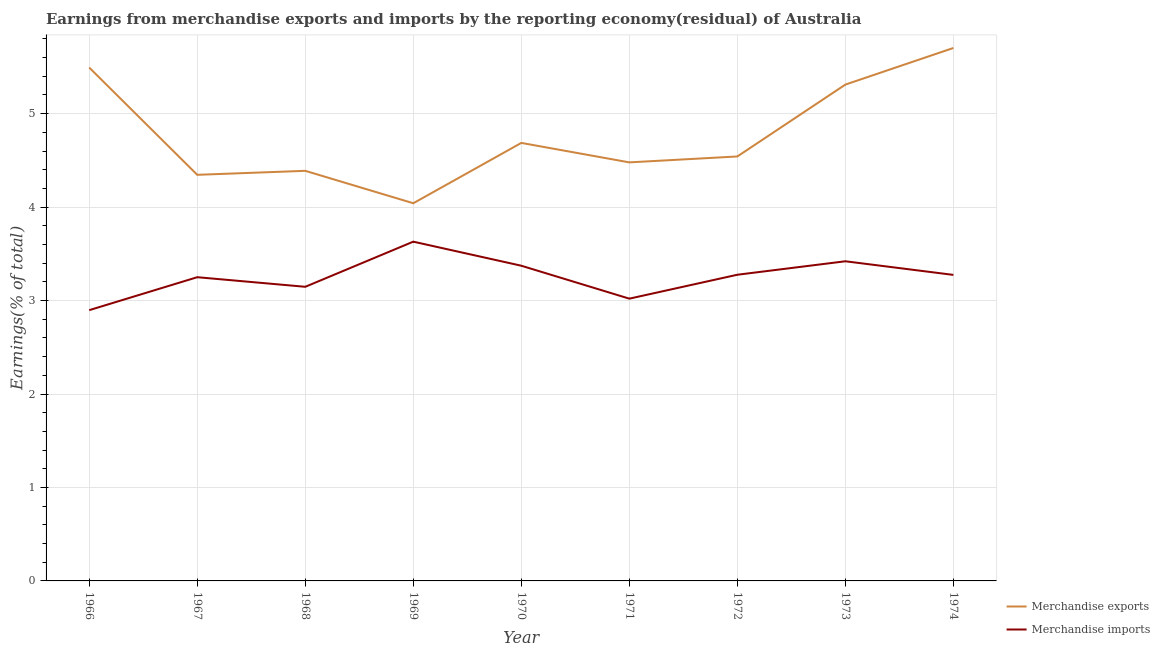Is the number of lines equal to the number of legend labels?
Provide a short and direct response. Yes. What is the earnings from merchandise imports in 1968?
Offer a very short reply. 3.15. Across all years, what is the maximum earnings from merchandise imports?
Offer a terse response. 3.63. Across all years, what is the minimum earnings from merchandise exports?
Offer a terse response. 4.04. In which year was the earnings from merchandise exports maximum?
Provide a short and direct response. 1974. In which year was the earnings from merchandise imports minimum?
Make the answer very short. 1966. What is the total earnings from merchandise exports in the graph?
Ensure brevity in your answer.  42.99. What is the difference between the earnings from merchandise imports in 1971 and that in 1972?
Provide a succinct answer. -0.26. What is the difference between the earnings from merchandise imports in 1974 and the earnings from merchandise exports in 1971?
Your response must be concise. -1.2. What is the average earnings from merchandise exports per year?
Offer a terse response. 4.78. In the year 1973, what is the difference between the earnings from merchandise exports and earnings from merchandise imports?
Offer a very short reply. 1.89. In how many years, is the earnings from merchandise exports greater than 4.4 %?
Keep it short and to the point. 6. What is the ratio of the earnings from merchandise exports in 1967 to that in 1971?
Offer a terse response. 0.97. Is the earnings from merchandise imports in 1970 less than that in 1974?
Your answer should be very brief. No. What is the difference between the highest and the second highest earnings from merchandise exports?
Your answer should be compact. 0.21. What is the difference between the highest and the lowest earnings from merchandise exports?
Ensure brevity in your answer.  1.66. Does the earnings from merchandise imports monotonically increase over the years?
Your answer should be compact. No. Is the earnings from merchandise imports strictly greater than the earnings from merchandise exports over the years?
Ensure brevity in your answer.  No. How many lines are there?
Provide a succinct answer. 2. Are the values on the major ticks of Y-axis written in scientific E-notation?
Give a very brief answer. No. Where does the legend appear in the graph?
Your response must be concise. Bottom right. How many legend labels are there?
Make the answer very short. 2. What is the title of the graph?
Keep it short and to the point. Earnings from merchandise exports and imports by the reporting economy(residual) of Australia. What is the label or title of the X-axis?
Ensure brevity in your answer.  Year. What is the label or title of the Y-axis?
Offer a very short reply. Earnings(% of total). What is the Earnings(% of total) in Merchandise exports in 1966?
Provide a short and direct response. 5.49. What is the Earnings(% of total) in Merchandise imports in 1966?
Offer a terse response. 2.9. What is the Earnings(% of total) of Merchandise exports in 1967?
Make the answer very short. 4.35. What is the Earnings(% of total) of Merchandise imports in 1967?
Your answer should be compact. 3.25. What is the Earnings(% of total) in Merchandise exports in 1968?
Ensure brevity in your answer.  4.39. What is the Earnings(% of total) in Merchandise imports in 1968?
Give a very brief answer. 3.15. What is the Earnings(% of total) of Merchandise exports in 1969?
Make the answer very short. 4.04. What is the Earnings(% of total) of Merchandise imports in 1969?
Your answer should be compact. 3.63. What is the Earnings(% of total) in Merchandise exports in 1970?
Make the answer very short. 4.69. What is the Earnings(% of total) of Merchandise imports in 1970?
Give a very brief answer. 3.37. What is the Earnings(% of total) of Merchandise exports in 1971?
Your answer should be very brief. 4.48. What is the Earnings(% of total) in Merchandise imports in 1971?
Your answer should be very brief. 3.02. What is the Earnings(% of total) in Merchandise exports in 1972?
Keep it short and to the point. 4.54. What is the Earnings(% of total) in Merchandise imports in 1972?
Your answer should be compact. 3.28. What is the Earnings(% of total) of Merchandise exports in 1973?
Your answer should be very brief. 5.31. What is the Earnings(% of total) of Merchandise imports in 1973?
Your response must be concise. 3.42. What is the Earnings(% of total) of Merchandise exports in 1974?
Make the answer very short. 5.7. What is the Earnings(% of total) in Merchandise imports in 1974?
Ensure brevity in your answer.  3.27. Across all years, what is the maximum Earnings(% of total) in Merchandise exports?
Offer a very short reply. 5.7. Across all years, what is the maximum Earnings(% of total) in Merchandise imports?
Provide a succinct answer. 3.63. Across all years, what is the minimum Earnings(% of total) in Merchandise exports?
Keep it short and to the point. 4.04. Across all years, what is the minimum Earnings(% of total) of Merchandise imports?
Provide a short and direct response. 2.9. What is the total Earnings(% of total) in Merchandise exports in the graph?
Make the answer very short. 42.99. What is the total Earnings(% of total) in Merchandise imports in the graph?
Give a very brief answer. 29.29. What is the difference between the Earnings(% of total) of Merchandise exports in 1966 and that in 1967?
Ensure brevity in your answer.  1.15. What is the difference between the Earnings(% of total) in Merchandise imports in 1966 and that in 1967?
Ensure brevity in your answer.  -0.35. What is the difference between the Earnings(% of total) of Merchandise exports in 1966 and that in 1968?
Keep it short and to the point. 1.1. What is the difference between the Earnings(% of total) of Merchandise exports in 1966 and that in 1969?
Provide a succinct answer. 1.45. What is the difference between the Earnings(% of total) of Merchandise imports in 1966 and that in 1969?
Keep it short and to the point. -0.73. What is the difference between the Earnings(% of total) of Merchandise exports in 1966 and that in 1970?
Give a very brief answer. 0.81. What is the difference between the Earnings(% of total) of Merchandise imports in 1966 and that in 1970?
Provide a short and direct response. -0.48. What is the difference between the Earnings(% of total) in Merchandise exports in 1966 and that in 1971?
Provide a short and direct response. 1.01. What is the difference between the Earnings(% of total) of Merchandise imports in 1966 and that in 1971?
Keep it short and to the point. -0.12. What is the difference between the Earnings(% of total) of Merchandise exports in 1966 and that in 1972?
Make the answer very short. 0.95. What is the difference between the Earnings(% of total) of Merchandise imports in 1966 and that in 1972?
Give a very brief answer. -0.38. What is the difference between the Earnings(% of total) of Merchandise exports in 1966 and that in 1973?
Give a very brief answer. 0.18. What is the difference between the Earnings(% of total) of Merchandise imports in 1966 and that in 1973?
Your answer should be very brief. -0.52. What is the difference between the Earnings(% of total) of Merchandise exports in 1966 and that in 1974?
Make the answer very short. -0.21. What is the difference between the Earnings(% of total) of Merchandise imports in 1966 and that in 1974?
Your response must be concise. -0.38. What is the difference between the Earnings(% of total) of Merchandise exports in 1967 and that in 1968?
Ensure brevity in your answer.  -0.04. What is the difference between the Earnings(% of total) in Merchandise imports in 1967 and that in 1968?
Give a very brief answer. 0.1. What is the difference between the Earnings(% of total) in Merchandise exports in 1967 and that in 1969?
Keep it short and to the point. 0.3. What is the difference between the Earnings(% of total) in Merchandise imports in 1967 and that in 1969?
Give a very brief answer. -0.38. What is the difference between the Earnings(% of total) in Merchandise exports in 1967 and that in 1970?
Make the answer very short. -0.34. What is the difference between the Earnings(% of total) in Merchandise imports in 1967 and that in 1970?
Ensure brevity in your answer.  -0.12. What is the difference between the Earnings(% of total) in Merchandise exports in 1967 and that in 1971?
Offer a terse response. -0.13. What is the difference between the Earnings(% of total) of Merchandise imports in 1967 and that in 1971?
Provide a succinct answer. 0.23. What is the difference between the Earnings(% of total) in Merchandise exports in 1967 and that in 1972?
Your answer should be very brief. -0.2. What is the difference between the Earnings(% of total) of Merchandise imports in 1967 and that in 1972?
Make the answer very short. -0.03. What is the difference between the Earnings(% of total) of Merchandise exports in 1967 and that in 1973?
Give a very brief answer. -0.97. What is the difference between the Earnings(% of total) of Merchandise imports in 1967 and that in 1973?
Provide a succinct answer. -0.17. What is the difference between the Earnings(% of total) in Merchandise exports in 1967 and that in 1974?
Ensure brevity in your answer.  -1.36. What is the difference between the Earnings(% of total) of Merchandise imports in 1967 and that in 1974?
Provide a succinct answer. -0.02. What is the difference between the Earnings(% of total) in Merchandise exports in 1968 and that in 1969?
Provide a succinct answer. 0.35. What is the difference between the Earnings(% of total) of Merchandise imports in 1968 and that in 1969?
Offer a very short reply. -0.48. What is the difference between the Earnings(% of total) in Merchandise exports in 1968 and that in 1970?
Offer a terse response. -0.3. What is the difference between the Earnings(% of total) in Merchandise imports in 1968 and that in 1970?
Make the answer very short. -0.23. What is the difference between the Earnings(% of total) of Merchandise exports in 1968 and that in 1971?
Offer a terse response. -0.09. What is the difference between the Earnings(% of total) in Merchandise imports in 1968 and that in 1971?
Offer a terse response. 0.13. What is the difference between the Earnings(% of total) in Merchandise exports in 1968 and that in 1972?
Make the answer very short. -0.15. What is the difference between the Earnings(% of total) in Merchandise imports in 1968 and that in 1972?
Give a very brief answer. -0.13. What is the difference between the Earnings(% of total) in Merchandise exports in 1968 and that in 1973?
Your answer should be very brief. -0.92. What is the difference between the Earnings(% of total) of Merchandise imports in 1968 and that in 1973?
Offer a very short reply. -0.27. What is the difference between the Earnings(% of total) in Merchandise exports in 1968 and that in 1974?
Offer a terse response. -1.31. What is the difference between the Earnings(% of total) of Merchandise imports in 1968 and that in 1974?
Provide a short and direct response. -0.13. What is the difference between the Earnings(% of total) of Merchandise exports in 1969 and that in 1970?
Offer a terse response. -0.65. What is the difference between the Earnings(% of total) in Merchandise imports in 1969 and that in 1970?
Provide a succinct answer. 0.26. What is the difference between the Earnings(% of total) of Merchandise exports in 1969 and that in 1971?
Provide a succinct answer. -0.44. What is the difference between the Earnings(% of total) in Merchandise imports in 1969 and that in 1971?
Make the answer very short. 0.61. What is the difference between the Earnings(% of total) of Merchandise exports in 1969 and that in 1972?
Your answer should be compact. -0.5. What is the difference between the Earnings(% of total) of Merchandise imports in 1969 and that in 1972?
Offer a very short reply. 0.35. What is the difference between the Earnings(% of total) in Merchandise exports in 1969 and that in 1973?
Make the answer very short. -1.27. What is the difference between the Earnings(% of total) in Merchandise imports in 1969 and that in 1973?
Provide a succinct answer. 0.21. What is the difference between the Earnings(% of total) in Merchandise exports in 1969 and that in 1974?
Provide a succinct answer. -1.66. What is the difference between the Earnings(% of total) in Merchandise imports in 1969 and that in 1974?
Offer a terse response. 0.36. What is the difference between the Earnings(% of total) in Merchandise exports in 1970 and that in 1971?
Provide a short and direct response. 0.21. What is the difference between the Earnings(% of total) in Merchandise imports in 1970 and that in 1971?
Your response must be concise. 0.35. What is the difference between the Earnings(% of total) in Merchandise exports in 1970 and that in 1972?
Offer a terse response. 0.14. What is the difference between the Earnings(% of total) of Merchandise imports in 1970 and that in 1972?
Make the answer very short. 0.1. What is the difference between the Earnings(% of total) of Merchandise exports in 1970 and that in 1973?
Your answer should be compact. -0.62. What is the difference between the Earnings(% of total) in Merchandise imports in 1970 and that in 1973?
Keep it short and to the point. -0.05. What is the difference between the Earnings(% of total) of Merchandise exports in 1970 and that in 1974?
Your answer should be compact. -1.02. What is the difference between the Earnings(% of total) of Merchandise imports in 1970 and that in 1974?
Offer a very short reply. 0.1. What is the difference between the Earnings(% of total) of Merchandise exports in 1971 and that in 1972?
Keep it short and to the point. -0.06. What is the difference between the Earnings(% of total) in Merchandise imports in 1971 and that in 1972?
Provide a short and direct response. -0.26. What is the difference between the Earnings(% of total) in Merchandise exports in 1971 and that in 1973?
Give a very brief answer. -0.83. What is the difference between the Earnings(% of total) in Merchandise imports in 1971 and that in 1973?
Provide a short and direct response. -0.4. What is the difference between the Earnings(% of total) in Merchandise exports in 1971 and that in 1974?
Make the answer very short. -1.22. What is the difference between the Earnings(% of total) in Merchandise imports in 1971 and that in 1974?
Your answer should be compact. -0.25. What is the difference between the Earnings(% of total) of Merchandise exports in 1972 and that in 1973?
Ensure brevity in your answer.  -0.77. What is the difference between the Earnings(% of total) in Merchandise imports in 1972 and that in 1973?
Provide a short and direct response. -0.14. What is the difference between the Earnings(% of total) of Merchandise exports in 1972 and that in 1974?
Make the answer very short. -1.16. What is the difference between the Earnings(% of total) of Merchandise imports in 1972 and that in 1974?
Provide a short and direct response. 0. What is the difference between the Earnings(% of total) of Merchandise exports in 1973 and that in 1974?
Give a very brief answer. -0.39. What is the difference between the Earnings(% of total) in Merchandise imports in 1973 and that in 1974?
Provide a short and direct response. 0.15. What is the difference between the Earnings(% of total) of Merchandise exports in 1966 and the Earnings(% of total) of Merchandise imports in 1967?
Provide a short and direct response. 2.24. What is the difference between the Earnings(% of total) of Merchandise exports in 1966 and the Earnings(% of total) of Merchandise imports in 1968?
Offer a terse response. 2.35. What is the difference between the Earnings(% of total) of Merchandise exports in 1966 and the Earnings(% of total) of Merchandise imports in 1969?
Your answer should be very brief. 1.86. What is the difference between the Earnings(% of total) of Merchandise exports in 1966 and the Earnings(% of total) of Merchandise imports in 1970?
Your answer should be very brief. 2.12. What is the difference between the Earnings(% of total) of Merchandise exports in 1966 and the Earnings(% of total) of Merchandise imports in 1971?
Your answer should be compact. 2.47. What is the difference between the Earnings(% of total) in Merchandise exports in 1966 and the Earnings(% of total) in Merchandise imports in 1972?
Make the answer very short. 2.22. What is the difference between the Earnings(% of total) in Merchandise exports in 1966 and the Earnings(% of total) in Merchandise imports in 1973?
Your answer should be very brief. 2.07. What is the difference between the Earnings(% of total) of Merchandise exports in 1966 and the Earnings(% of total) of Merchandise imports in 1974?
Offer a terse response. 2.22. What is the difference between the Earnings(% of total) in Merchandise exports in 1967 and the Earnings(% of total) in Merchandise imports in 1968?
Your response must be concise. 1.2. What is the difference between the Earnings(% of total) in Merchandise exports in 1967 and the Earnings(% of total) in Merchandise imports in 1969?
Provide a succinct answer. 0.72. What is the difference between the Earnings(% of total) in Merchandise exports in 1967 and the Earnings(% of total) in Merchandise imports in 1970?
Offer a terse response. 0.97. What is the difference between the Earnings(% of total) in Merchandise exports in 1967 and the Earnings(% of total) in Merchandise imports in 1971?
Provide a short and direct response. 1.33. What is the difference between the Earnings(% of total) in Merchandise exports in 1967 and the Earnings(% of total) in Merchandise imports in 1972?
Your answer should be very brief. 1.07. What is the difference between the Earnings(% of total) in Merchandise exports in 1967 and the Earnings(% of total) in Merchandise imports in 1973?
Keep it short and to the point. 0.93. What is the difference between the Earnings(% of total) of Merchandise exports in 1967 and the Earnings(% of total) of Merchandise imports in 1974?
Make the answer very short. 1.07. What is the difference between the Earnings(% of total) in Merchandise exports in 1968 and the Earnings(% of total) in Merchandise imports in 1969?
Offer a terse response. 0.76. What is the difference between the Earnings(% of total) of Merchandise exports in 1968 and the Earnings(% of total) of Merchandise imports in 1970?
Make the answer very short. 1.02. What is the difference between the Earnings(% of total) in Merchandise exports in 1968 and the Earnings(% of total) in Merchandise imports in 1971?
Your response must be concise. 1.37. What is the difference between the Earnings(% of total) of Merchandise exports in 1968 and the Earnings(% of total) of Merchandise imports in 1972?
Offer a very short reply. 1.11. What is the difference between the Earnings(% of total) of Merchandise exports in 1968 and the Earnings(% of total) of Merchandise imports in 1974?
Ensure brevity in your answer.  1.11. What is the difference between the Earnings(% of total) in Merchandise exports in 1969 and the Earnings(% of total) in Merchandise imports in 1970?
Your answer should be compact. 0.67. What is the difference between the Earnings(% of total) of Merchandise exports in 1969 and the Earnings(% of total) of Merchandise imports in 1971?
Your answer should be compact. 1.02. What is the difference between the Earnings(% of total) of Merchandise exports in 1969 and the Earnings(% of total) of Merchandise imports in 1972?
Make the answer very short. 0.77. What is the difference between the Earnings(% of total) in Merchandise exports in 1969 and the Earnings(% of total) in Merchandise imports in 1973?
Provide a short and direct response. 0.62. What is the difference between the Earnings(% of total) in Merchandise exports in 1969 and the Earnings(% of total) in Merchandise imports in 1974?
Provide a short and direct response. 0.77. What is the difference between the Earnings(% of total) in Merchandise exports in 1970 and the Earnings(% of total) in Merchandise imports in 1971?
Your answer should be very brief. 1.67. What is the difference between the Earnings(% of total) of Merchandise exports in 1970 and the Earnings(% of total) of Merchandise imports in 1972?
Provide a succinct answer. 1.41. What is the difference between the Earnings(% of total) of Merchandise exports in 1970 and the Earnings(% of total) of Merchandise imports in 1973?
Your response must be concise. 1.27. What is the difference between the Earnings(% of total) in Merchandise exports in 1970 and the Earnings(% of total) in Merchandise imports in 1974?
Offer a terse response. 1.41. What is the difference between the Earnings(% of total) of Merchandise exports in 1971 and the Earnings(% of total) of Merchandise imports in 1972?
Provide a short and direct response. 1.2. What is the difference between the Earnings(% of total) of Merchandise exports in 1971 and the Earnings(% of total) of Merchandise imports in 1973?
Offer a terse response. 1.06. What is the difference between the Earnings(% of total) of Merchandise exports in 1971 and the Earnings(% of total) of Merchandise imports in 1974?
Keep it short and to the point. 1.2. What is the difference between the Earnings(% of total) in Merchandise exports in 1972 and the Earnings(% of total) in Merchandise imports in 1973?
Ensure brevity in your answer.  1.12. What is the difference between the Earnings(% of total) in Merchandise exports in 1972 and the Earnings(% of total) in Merchandise imports in 1974?
Your answer should be compact. 1.27. What is the difference between the Earnings(% of total) of Merchandise exports in 1973 and the Earnings(% of total) of Merchandise imports in 1974?
Make the answer very short. 2.04. What is the average Earnings(% of total) in Merchandise exports per year?
Your answer should be compact. 4.78. What is the average Earnings(% of total) in Merchandise imports per year?
Provide a succinct answer. 3.25. In the year 1966, what is the difference between the Earnings(% of total) in Merchandise exports and Earnings(% of total) in Merchandise imports?
Give a very brief answer. 2.6. In the year 1967, what is the difference between the Earnings(% of total) in Merchandise exports and Earnings(% of total) in Merchandise imports?
Ensure brevity in your answer.  1.1. In the year 1968, what is the difference between the Earnings(% of total) of Merchandise exports and Earnings(% of total) of Merchandise imports?
Your answer should be compact. 1.24. In the year 1969, what is the difference between the Earnings(% of total) of Merchandise exports and Earnings(% of total) of Merchandise imports?
Offer a very short reply. 0.41. In the year 1970, what is the difference between the Earnings(% of total) of Merchandise exports and Earnings(% of total) of Merchandise imports?
Offer a terse response. 1.31. In the year 1971, what is the difference between the Earnings(% of total) of Merchandise exports and Earnings(% of total) of Merchandise imports?
Provide a short and direct response. 1.46. In the year 1972, what is the difference between the Earnings(% of total) in Merchandise exports and Earnings(% of total) in Merchandise imports?
Give a very brief answer. 1.27. In the year 1973, what is the difference between the Earnings(% of total) of Merchandise exports and Earnings(% of total) of Merchandise imports?
Keep it short and to the point. 1.89. In the year 1974, what is the difference between the Earnings(% of total) of Merchandise exports and Earnings(% of total) of Merchandise imports?
Provide a succinct answer. 2.43. What is the ratio of the Earnings(% of total) in Merchandise exports in 1966 to that in 1967?
Make the answer very short. 1.26. What is the ratio of the Earnings(% of total) in Merchandise imports in 1966 to that in 1967?
Make the answer very short. 0.89. What is the ratio of the Earnings(% of total) of Merchandise exports in 1966 to that in 1968?
Your answer should be very brief. 1.25. What is the ratio of the Earnings(% of total) in Merchandise imports in 1966 to that in 1968?
Keep it short and to the point. 0.92. What is the ratio of the Earnings(% of total) of Merchandise exports in 1966 to that in 1969?
Offer a very short reply. 1.36. What is the ratio of the Earnings(% of total) in Merchandise imports in 1966 to that in 1969?
Make the answer very short. 0.8. What is the ratio of the Earnings(% of total) of Merchandise exports in 1966 to that in 1970?
Keep it short and to the point. 1.17. What is the ratio of the Earnings(% of total) of Merchandise imports in 1966 to that in 1970?
Your answer should be very brief. 0.86. What is the ratio of the Earnings(% of total) in Merchandise exports in 1966 to that in 1971?
Offer a terse response. 1.23. What is the ratio of the Earnings(% of total) of Merchandise imports in 1966 to that in 1971?
Provide a short and direct response. 0.96. What is the ratio of the Earnings(% of total) in Merchandise exports in 1966 to that in 1972?
Offer a very short reply. 1.21. What is the ratio of the Earnings(% of total) in Merchandise imports in 1966 to that in 1972?
Your response must be concise. 0.88. What is the ratio of the Earnings(% of total) of Merchandise exports in 1966 to that in 1973?
Make the answer very short. 1.03. What is the ratio of the Earnings(% of total) of Merchandise imports in 1966 to that in 1973?
Provide a succinct answer. 0.85. What is the ratio of the Earnings(% of total) in Merchandise exports in 1966 to that in 1974?
Provide a succinct answer. 0.96. What is the ratio of the Earnings(% of total) in Merchandise imports in 1966 to that in 1974?
Keep it short and to the point. 0.88. What is the ratio of the Earnings(% of total) in Merchandise exports in 1967 to that in 1968?
Give a very brief answer. 0.99. What is the ratio of the Earnings(% of total) in Merchandise imports in 1967 to that in 1968?
Give a very brief answer. 1.03. What is the ratio of the Earnings(% of total) in Merchandise exports in 1967 to that in 1969?
Keep it short and to the point. 1.08. What is the ratio of the Earnings(% of total) of Merchandise imports in 1967 to that in 1969?
Provide a short and direct response. 0.9. What is the ratio of the Earnings(% of total) of Merchandise exports in 1967 to that in 1970?
Make the answer very short. 0.93. What is the ratio of the Earnings(% of total) in Merchandise imports in 1967 to that in 1970?
Keep it short and to the point. 0.96. What is the ratio of the Earnings(% of total) of Merchandise exports in 1967 to that in 1971?
Keep it short and to the point. 0.97. What is the ratio of the Earnings(% of total) in Merchandise imports in 1967 to that in 1971?
Offer a terse response. 1.08. What is the ratio of the Earnings(% of total) in Merchandise exports in 1967 to that in 1972?
Your answer should be compact. 0.96. What is the ratio of the Earnings(% of total) of Merchandise exports in 1967 to that in 1973?
Your response must be concise. 0.82. What is the ratio of the Earnings(% of total) in Merchandise imports in 1967 to that in 1973?
Provide a succinct answer. 0.95. What is the ratio of the Earnings(% of total) of Merchandise exports in 1967 to that in 1974?
Offer a very short reply. 0.76. What is the ratio of the Earnings(% of total) in Merchandise exports in 1968 to that in 1969?
Keep it short and to the point. 1.09. What is the ratio of the Earnings(% of total) of Merchandise imports in 1968 to that in 1969?
Provide a succinct answer. 0.87. What is the ratio of the Earnings(% of total) of Merchandise exports in 1968 to that in 1970?
Offer a terse response. 0.94. What is the ratio of the Earnings(% of total) of Merchandise imports in 1968 to that in 1970?
Your answer should be very brief. 0.93. What is the ratio of the Earnings(% of total) of Merchandise exports in 1968 to that in 1971?
Offer a very short reply. 0.98. What is the ratio of the Earnings(% of total) of Merchandise imports in 1968 to that in 1971?
Give a very brief answer. 1.04. What is the ratio of the Earnings(% of total) of Merchandise exports in 1968 to that in 1972?
Your response must be concise. 0.97. What is the ratio of the Earnings(% of total) of Merchandise imports in 1968 to that in 1972?
Provide a succinct answer. 0.96. What is the ratio of the Earnings(% of total) of Merchandise exports in 1968 to that in 1973?
Offer a terse response. 0.83. What is the ratio of the Earnings(% of total) in Merchandise imports in 1968 to that in 1973?
Give a very brief answer. 0.92. What is the ratio of the Earnings(% of total) in Merchandise exports in 1968 to that in 1974?
Your response must be concise. 0.77. What is the ratio of the Earnings(% of total) in Merchandise imports in 1968 to that in 1974?
Offer a terse response. 0.96. What is the ratio of the Earnings(% of total) of Merchandise exports in 1969 to that in 1970?
Your answer should be compact. 0.86. What is the ratio of the Earnings(% of total) of Merchandise imports in 1969 to that in 1970?
Offer a very short reply. 1.08. What is the ratio of the Earnings(% of total) in Merchandise exports in 1969 to that in 1971?
Your answer should be very brief. 0.9. What is the ratio of the Earnings(% of total) of Merchandise imports in 1969 to that in 1971?
Your answer should be compact. 1.2. What is the ratio of the Earnings(% of total) of Merchandise exports in 1969 to that in 1972?
Your answer should be very brief. 0.89. What is the ratio of the Earnings(% of total) of Merchandise imports in 1969 to that in 1972?
Your response must be concise. 1.11. What is the ratio of the Earnings(% of total) of Merchandise exports in 1969 to that in 1973?
Offer a very short reply. 0.76. What is the ratio of the Earnings(% of total) in Merchandise imports in 1969 to that in 1973?
Provide a succinct answer. 1.06. What is the ratio of the Earnings(% of total) of Merchandise exports in 1969 to that in 1974?
Offer a very short reply. 0.71. What is the ratio of the Earnings(% of total) of Merchandise imports in 1969 to that in 1974?
Your answer should be very brief. 1.11. What is the ratio of the Earnings(% of total) in Merchandise exports in 1970 to that in 1971?
Offer a very short reply. 1.05. What is the ratio of the Earnings(% of total) in Merchandise imports in 1970 to that in 1971?
Give a very brief answer. 1.12. What is the ratio of the Earnings(% of total) in Merchandise exports in 1970 to that in 1972?
Your answer should be very brief. 1.03. What is the ratio of the Earnings(% of total) of Merchandise imports in 1970 to that in 1972?
Your answer should be very brief. 1.03. What is the ratio of the Earnings(% of total) in Merchandise exports in 1970 to that in 1973?
Give a very brief answer. 0.88. What is the ratio of the Earnings(% of total) in Merchandise imports in 1970 to that in 1973?
Offer a terse response. 0.99. What is the ratio of the Earnings(% of total) of Merchandise exports in 1970 to that in 1974?
Your answer should be very brief. 0.82. What is the ratio of the Earnings(% of total) of Merchandise imports in 1970 to that in 1974?
Provide a short and direct response. 1.03. What is the ratio of the Earnings(% of total) of Merchandise exports in 1971 to that in 1972?
Your answer should be compact. 0.99. What is the ratio of the Earnings(% of total) of Merchandise imports in 1971 to that in 1972?
Provide a short and direct response. 0.92. What is the ratio of the Earnings(% of total) of Merchandise exports in 1971 to that in 1973?
Your answer should be very brief. 0.84. What is the ratio of the Earnings(% of total) of Merchandise imports in 1971 to that in 1973?
Offer a very short reply. 0.88. What is the ratio of the Earnings(% of total) of Merchandise exports in 1971 to that in 1974?
Provide a short and direct response. 0.79. What is the ratio of the Earnings(% of total) of Merchandise imports in 1971 to that in 1974?
Keep it short and to the point. 0.92. What is the ratio of the Earnings(% of total) of Merchandise exports in 1972 to that in 1973?
Offer a terse response. 0.86. What is the ratio of the Earnings(% of total) of Merchandise imports in 1972 to that in 1973?
Your answer should be very brief. 0.96. What is the ratio of the Earnings(% of total) in Merchandise exports in 1972 to that in 1974?
Keep it short and to the point. 0.8. What is the ratio of the Earnings(% of total) of Merchandise exports in 1973 to that in 1974?
Make the answer very short. 0.93. What is the ratio of the Earnings(% of total) of Merchandise imports in 1973 to that in 1974?
Offer a terse response. 1.04. What is the difference between the highest and the second highest Earnings(% of total) of Merchandise exports?
Make the answer very short. 0.21. What is the difference between the highest and the second highest Earnings(% of total) in Merchandise imports?
Offer a terse response. 0.21. What is the difference between the highest and the lowest Earnings(% of total) of Merchandise exports?
Your response must be concise. 1.66. What is the difference between the highest and the lowest Earnings(% of total) in Merchandise imports?
Offer a terse response. 0.73. 